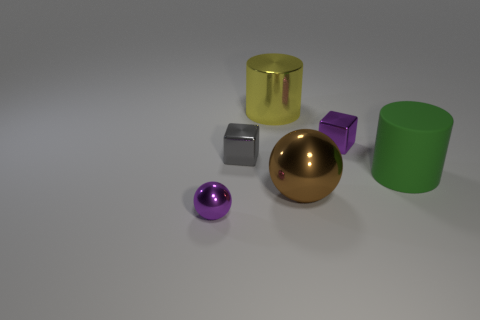There is a small metal thing that is in front of the green cylinder; what shape is it?
Offer a terse response. Sphere. There is a tiny purple metal thing left of the brown object; is it the same shape as the big metal thing that is behind the purple shiny block?
Keep it short and to the point. No. Is the number of brown spheres on the right side of the brown metal sphere the same as the number of big brown shiny spheres?
Make the answer very short. No. Is there any other thing that has the same size as the yellow metal object?
Make the answer very short. Yes. There is a large green object that is the same shape as the large yellow thing; what is it made of?
Provide a short and direct response. Rubber. There is a purple thing on the left side of the tiny purple metallic thing right of the small gray cube; what shape is it?
Provide a succinct answer. Sphere. Do the big cylinder that is to the right of the big yellow shiny cylinder and the purple ball have the same material?
Provide a short and direct response. No. Are there the same number of small gray metallic things on the left side of the purple sphere and yellow metal objects that are right of the purple shiny cube?
Provide a short and direct response. Yes. What is the material of the small thing that is the same color as the small metallic ball?
Your answer should be compact. Metal. There is a small purple object on the right side of the purple sphere; what number of tiny cubes are in front of it?
Keep it short and to the point. 1. 